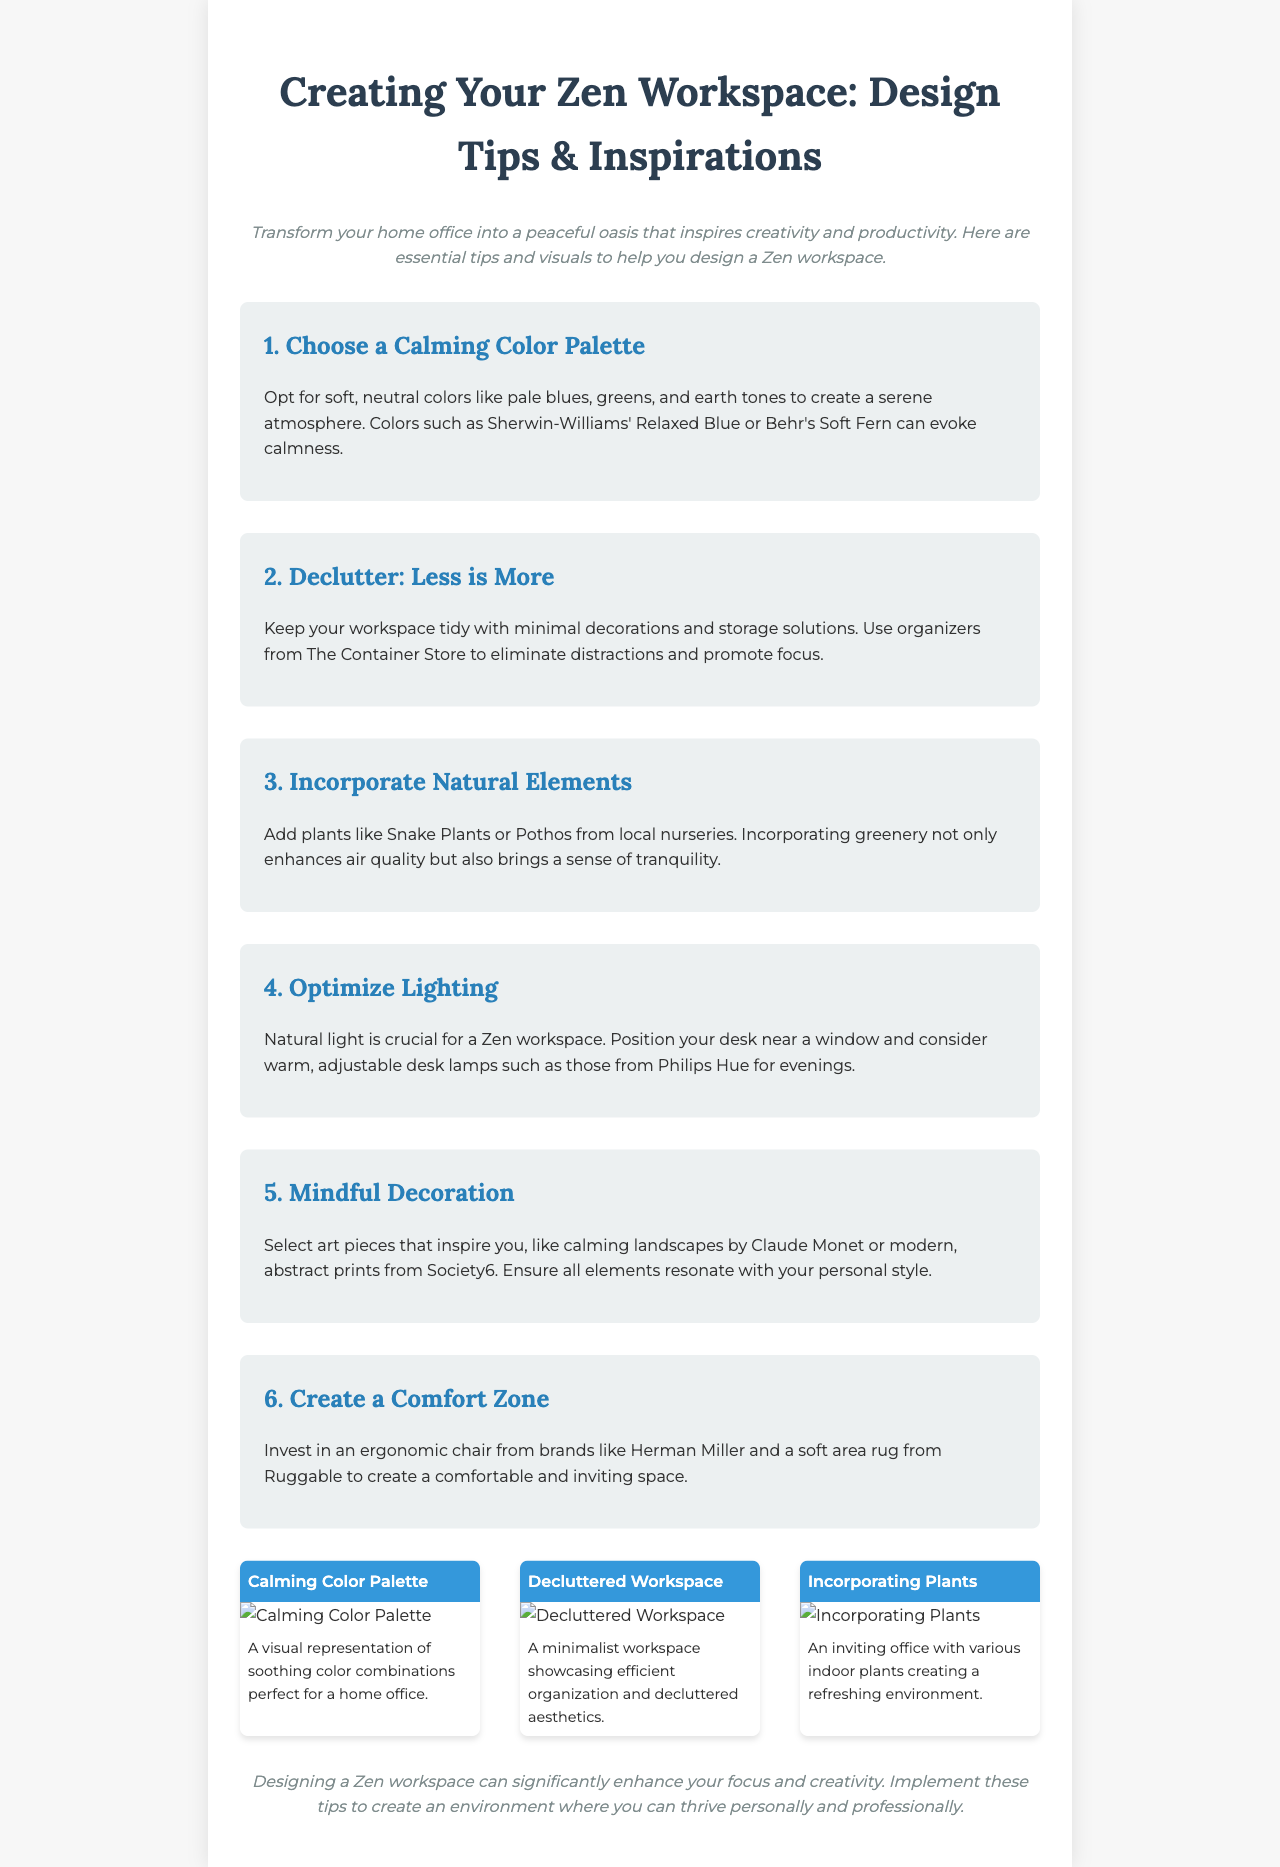What are the calming colors suggested? The document mentions soft, neutral colors like pale blues, greens, and earth tones as calming colors.
Answer: pale blues, greens, earth tones Which brand is recommended for ergonomic chairs? The document suggests investing in ergonomic chairs from the brand Herman Miller.
Answer: Herman Miller What is the title of section 5? The title of section 5 discusses decoration that promotes mindfulness.
Answer: Mindful Decoration How many visual inspiration images are presented? The document features a total of three images under visual inspiration.
Answer: 3 What type of light is essential for a Zen workspace? According to the document, natural light is crucial for creating a Zen workspace.
Answer: Natural light What should be minimized in the workspace according to Tip 2? The document advises keeping decorations and clutter to a minimum as part of Tip 2.
Answer: Clutter Which type of plants are suggested for incorporation? The document recommends incorporating Snake Plants or Pothos for enhancing the workspace.
Answer: Snake Plants, Pothos What is the main goal of designing a Zen workspace? The conclusion emphasizes that a Zen workspace significantly enhances focus and creativity.
Answer: Enhance focus and creativity 